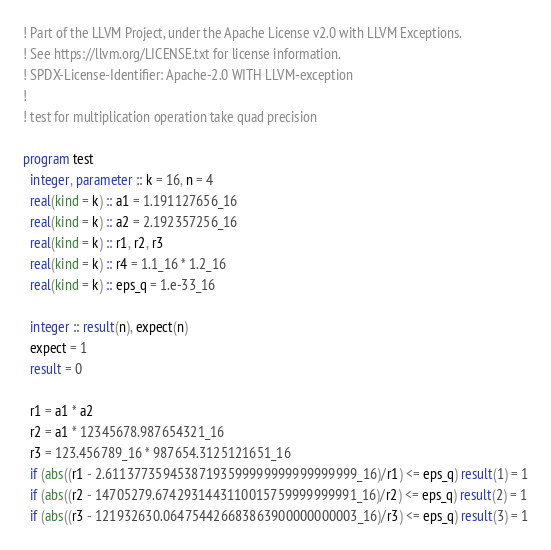<code> <loc_0><loc_0><loc_500><loc_500><_FORTRAN_>! Part of the LLVM Project, under the Apache License v2.0 with LLVM Exceptions.
! See https://llvm.org/LICENSE.txt for license information.
! SPDX-License-Identifier: Apache-2.0 WITH LLVM-exception
!
! test for multiplication operation take quad precision

program test
  integer, parameter :: k = 16, n = 4
  real(kind = k) :: a1 = 1.191127656_16
  real(kind = k) :: a2 = 2.192357256_16
  real(kind = k) :: r1, r2, r3
  real(kind = k) :: r4 = 1.1_16 * 1.2_16
  real(kind = k) :: eps_q = 1.e-33_16

  integer :: result(n), expect(n)
  expect = 1
  result = 0

  r1 = a1 * a2
  r2 = a1 * 12345678.987654321_16
  r3 = 123.456789_16 * 987654.3125121651_16
  if (abs((r1 - 2.61137735945387193599999999999999999_16)/r1) <= eps_q) result(1) = 1
  if (abs((r2 - 14705279.6742931443110015759999999991_16)/r2) <= eps_q) result(2) = 1
  if (abs((r3 - 121932630.064754426683863900000000003_16)/r3) <= eps_q) result(3) = 1</code> 